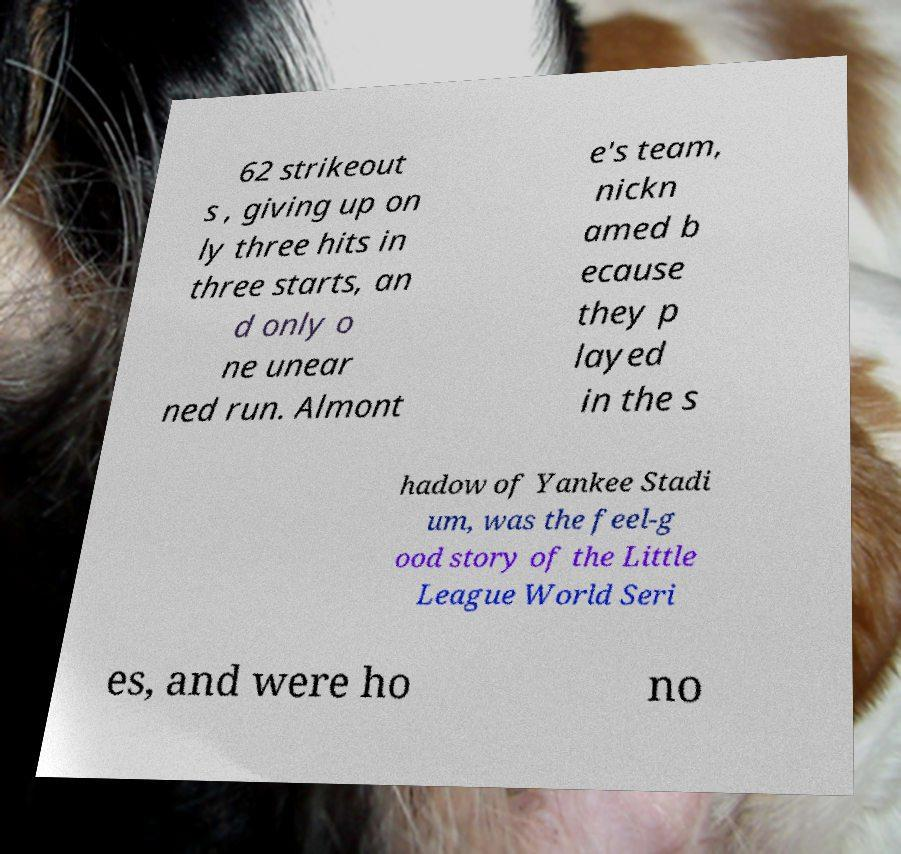Please identify and transcribe the text found in this image. 62 strikeout s , giving up on ly three hits in three starts, an d only o ne unear ned run. Almont e's team, nickn amed b ecause they p layed in the s hadow of Yankee Stadi um, was the feel-g ood story of the Little League World Seri es, and were ho no 